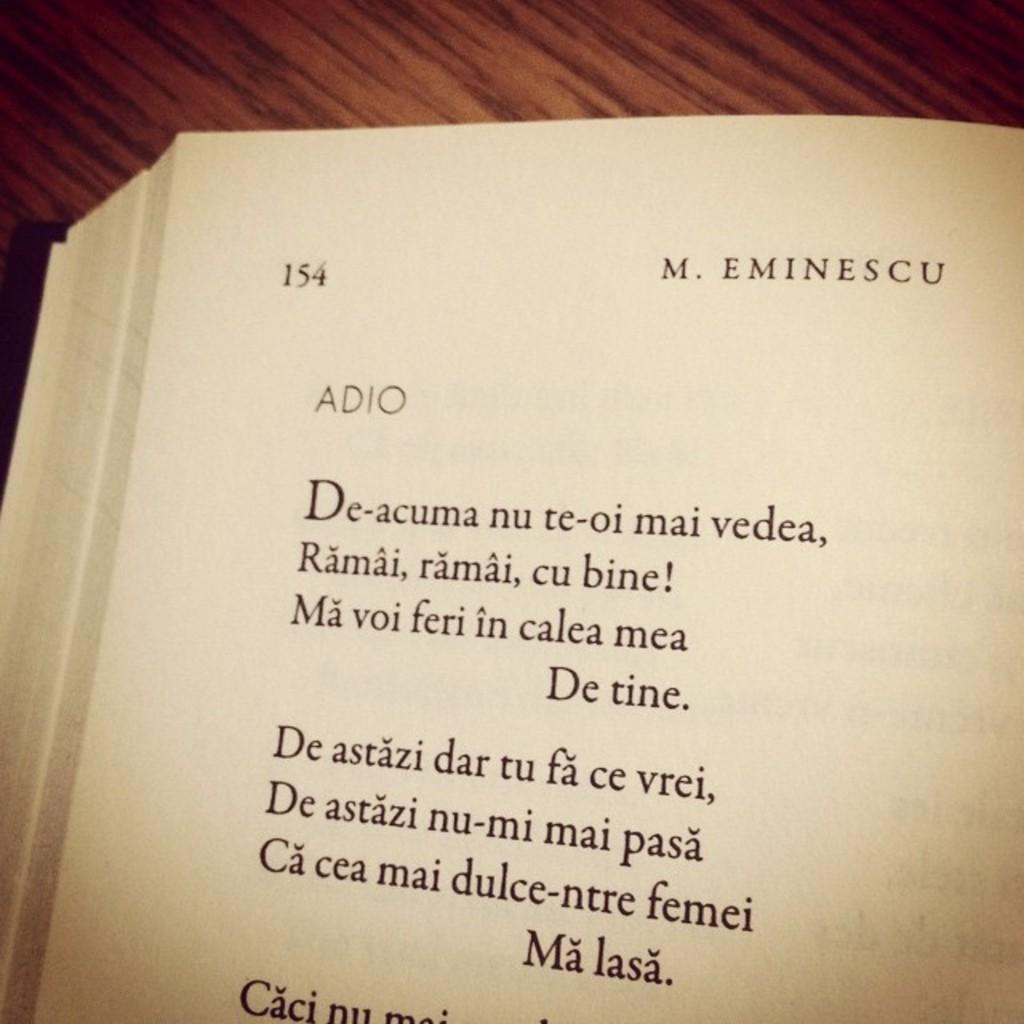How would you summarize this image in a sentence or two? In the center of this picture we can see a book and we can see the text and numbers on the paper of the book. In the background we can see an object seems to be the table. 